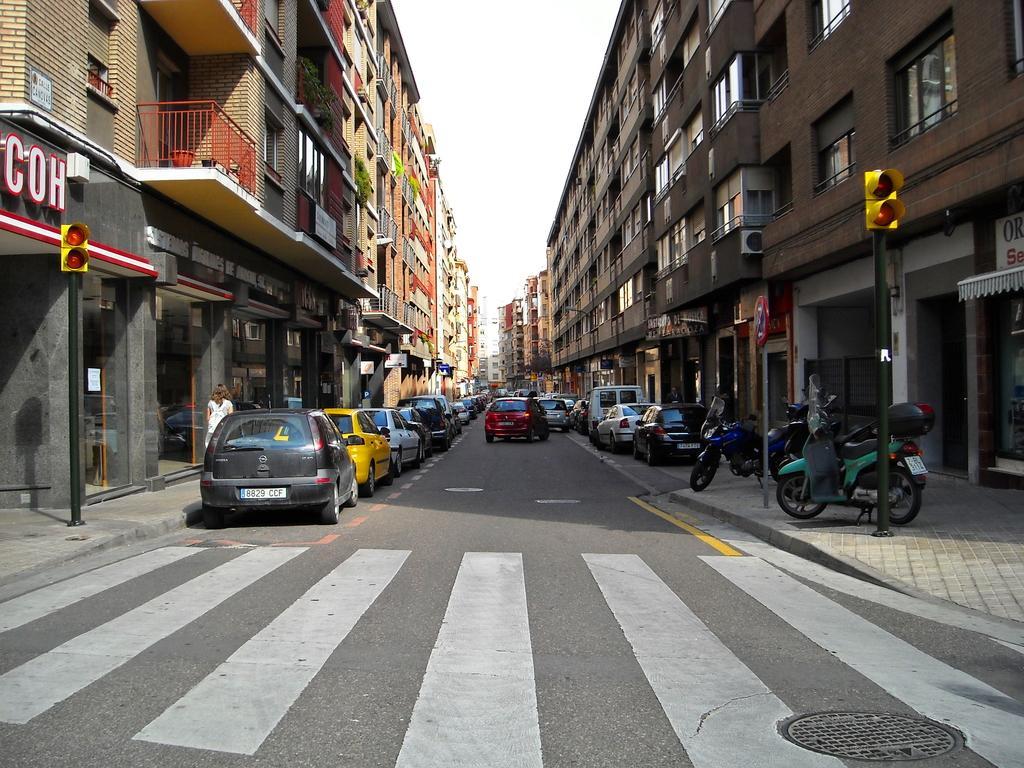In one or two sentences, can you explain what this image depicts? This is the road, on the left side few cars are parked on it. These are the buildings on either side of this road. 